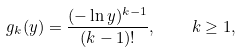Convert formula to latex. <formula><loc_0><loc_0><loc_500><loc_500>g _ { k } ( y ) = \frac { ( - \ln y ) ^ { k - 1 } } { ( k - 1 ) ! } , \quad k \geq 1 ,</formula> 